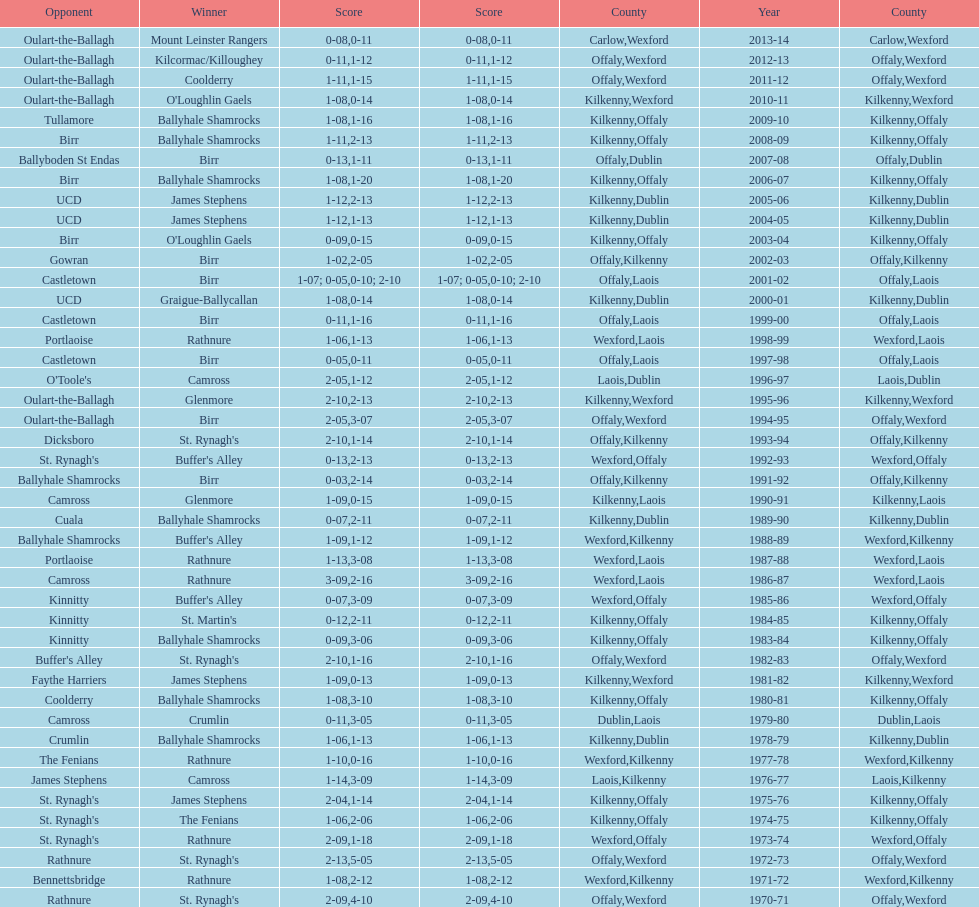Would you mind parsing the complete table? {'header': ['Opponent', 'Winner', 'Score', 'Score', 'County', 'Year', 'County'], 'rows': [['Oulart-the-Ballagh', 'Mount Leinster Rangers', '0-08', '0-11', 'Carlow', '2013-14', 'Wexford'], ['Oulart-the-Ballagh', 'Kilcormac/Killoughey', '0-11', '1-12', 'Offaly', '2012-13', 'Wexford'], ['Oulart-the-Ballagh', 'Coolderry', '1-11', '1-15', 'Offaly', '2011-12', 'Wexford'], ['Oulart-the-Ballagh', "O'Loughlin Gaels", '1-08', '0-14', 'Kilkenny', '2010-11', 'Wexford'], ['Tullamore', 'Ballyhale Shamrocks', '1-08', '1-16', 'Kilkenny', '2009-10', 'Offaly'], ['Birr', 'Ballyhale Shamrocks', '1-11', '2-13', 'Kilkenny', '2008-09', 'Offaly'], ['Ballyboden St Endas', 'Birr', '0-13', '1-11', 'Offaly', '2007-08', 'Dublin'], ['Birr', 'Ballyhale Shamrocks', '1-08', '1-20', 'Kilkenny', '2006-07', 'Offaly'], ['UCD', 'James Stephens', '1-12', '2-13', 'Kilkenny', '2005-06', 'Dublin'], ['UCD', 'James Stephens', '1-12', '1-13', 'Kilkenny', '2004-05', 'Dublin'], ['Birr', "O'Loughlin Gaels", '0-09', '0-15', 'Kilkenny', '2003-04', 'Offaly'], ['Gowran', 'Birr', '1-02', '2-05', 'Offaly', '2002-03', 'Kilkenny'], ['Castletown', 'Birr', '1-07; 0-05', '0-10; 2-10', 'Offaly', '2001-02', 'Laois'], ['UCD', 'Graigue-Ballycallan', '1-08', '0-14', 'Kilkenny', '2000-01', 'Dublin'], ['Castletown', 'Birr', '0-11', '1-16', 'Offaly', '1999-00', 'Laois'], ['Portlaoise', 'Rathnure', '1-06', '1-13', 'Wexford', '1998-99', 'Laois'], ['Castletown', 'Birr', '0-05', '0-11', 'Offaly', '1997-98', 'Laois'], ["O'Toole's", 'Camross', '2-05', '1-12', 'Laois', '1996-97', 'Dublin'], ['Oulart-the-Ballagh', 'Glenmore', '2-10', '2-13', 'Kilkenny', '1995-96', 'Wexford'], ['Oulart-the-Ballagh', 'Birr', '2-05', '3-07', 'Offaly', '1994-95', 'Wexford'], ['Dicksboro', "St. Rynagh's", '2-10', '1-14', 'Offaly', '1993-94', 'Kilkenny'], ["St. Rynagh's", "Buffer's Alley", '0-13', '2-13', 'Wexford', '1992-93', 'Offaly'], ['Ballyhale Shamrocks', 'Birr', '0-03', '2-14', 'Offaly', '1991-92', 'Kilkenny'], ['Camross', 'Glenmore', '1-09', '0-15', 'Kilkenny', '1990-91', 'Laois'], ['Cuala', 'Ballyhale Shamrocks', '0-07', '2-11', 'Kilkenny', '1989-90', 'Dublin'], ['Ballyhale Shamrocks', "Buffer's Alley", '1-09', '1-12', 'Wexford', '1988-89', 'Kilkenny'], ['Portlaoise', 'Rathnure', '1-13', '3-08', 'Wexford', '1987-88', 'Laois'], ['Camross', 'Rathnure', '3-09', '2-16', 'Wexford', '1986-87', 'Laois'], ['Kinnitty', "Buffer's Alley", '0-07', '3-09', 'Wexford', '1985-86', 'Offaly'], ['Kinnitty', "St. Martin's", '0-12', '2-11', 'Kilkenny', '1984-85', 'Offaly'], ['Kinnitty', 'Ballyhale Shamrocks', '0-09', '3-06', 'Kilkenny', '1983-84', 'Offaly'], ["Buffer's Alley", "St. Rynagh's", '2-10', '1-16', 'Offaly', '1982-83', 'Wexford'], ['Faythe Harriers', 'James Stephens', '1-09', '0-13', 'Kilkenny', '1981-82', 'Wexford'], ['Coolderry', 'Ballyhale Shamrocks', '1-08', '3-10', 'Kilkenny', '1980-81', 'Offaly'], ['Camross', 'Crumlin', '0-11', '3-05', 'Dublin', '1979-80', 'Laois'], ['Crumlin', 'Ballyhale Shamrocks', '1-06', '1-13', 'Kilkenny', '1978-79', 'Dublin'], ['The Fenians', 'Rathnure', '1-10', '0-16', 'Wexford', '1977-78', 'Kilkenny'], ['James Stephens', 'Camross', '1-14', '3-09', 'Laois', '1976-77', 'Kilkenny'], ["St. Rynagh's", 'James Stephens', '2-04', '1-14', 'Kilkenny', '1975-76', 'Offaly'], ["St. Rynagh's", 'The Fenians', '1-06', '2-06', 'Kilkenny', '1974-75', 'Offaly'], ["St. Rynagh's", 'Rathnure', '2-09', '1-18', 'Wexford', '1973-74', 'Offaly'], ['Rathnure', "St. Rynagh's", '2-13', '5-05', 'Offaly', '1972-73', 'Wexford'], ['Bennettsbridge', 'Rathnure', '1-08', '2-12', 'Wexford', '1971-72', 'Kilkenny'], ['Rathnure', "St. Rynagh's", '2-09', '4-10', 'Offaly', '1970-71', 'Wexford']]} What was the last season the leinster senior club hurling championships was won by a score differential of less than 11? 2007-08. 